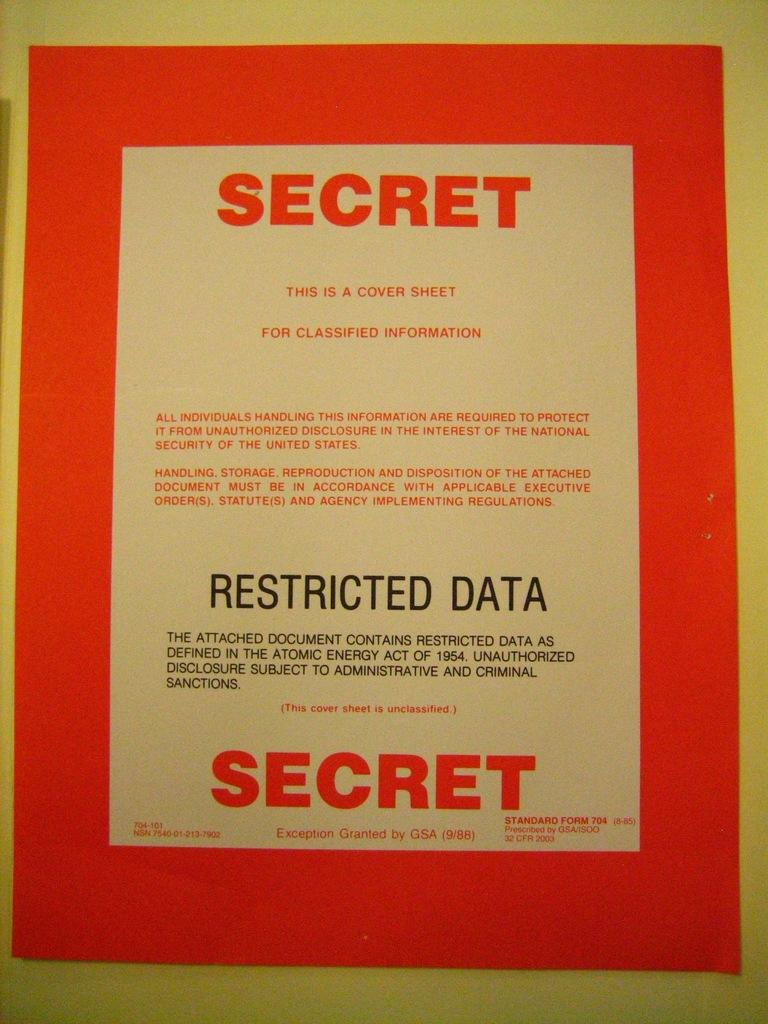<image>
Relay a brief, clear account of the picture shown. Poster taht says Secret on top and the bottom in red words. 